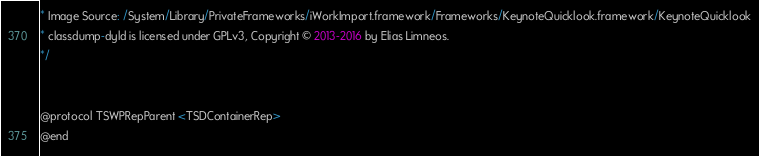Convert code to text. <code><loc_0><loc_0><loc_500><loc_500><_C_>* Image Source: /System/Library/PrivateFrameworks/iWorkImport.framework/Frameworks/KeynoteQuicklook.framework/KeynoteQuicklook
* classdump-dyld is licensed under GPLv3, Copyright © 2013-2016 by Elias Limneos.
*/


@protocol TSWPRepParent <TSDContainerRep>
@end

</code> 